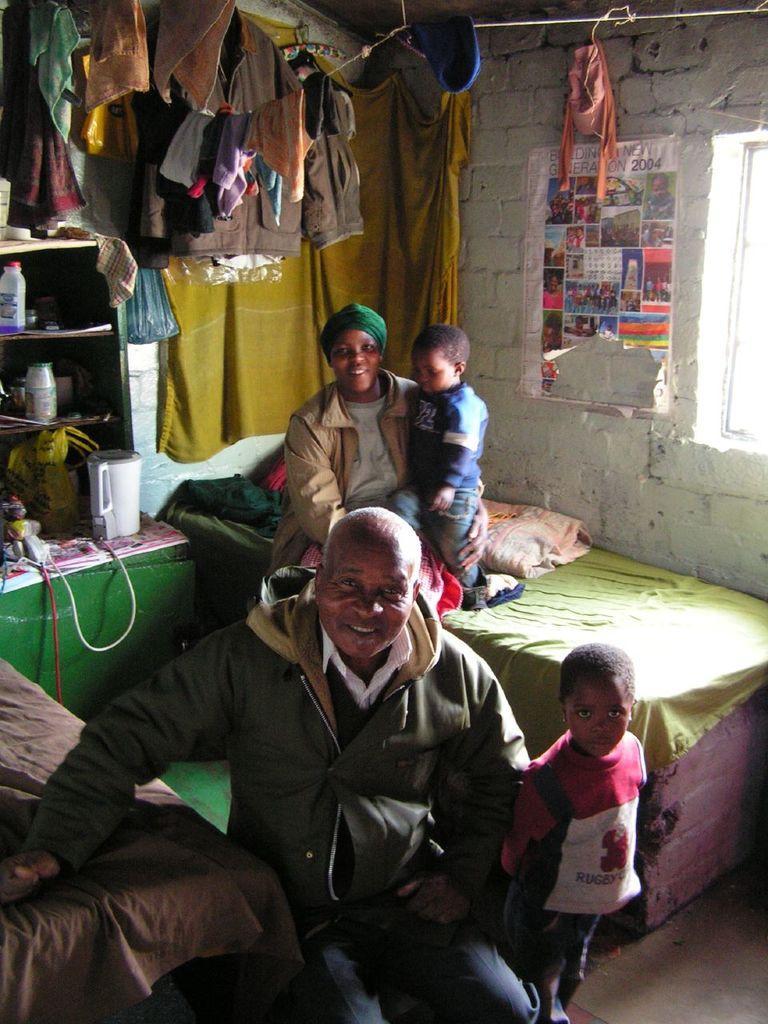Can you describe this image briefly? In this picture I can see a man and a woman, there are two kids, there is a paper on the wall, there is a window, there are clothes, blankets, there are some items in the rack, and in the background there are some objects. 